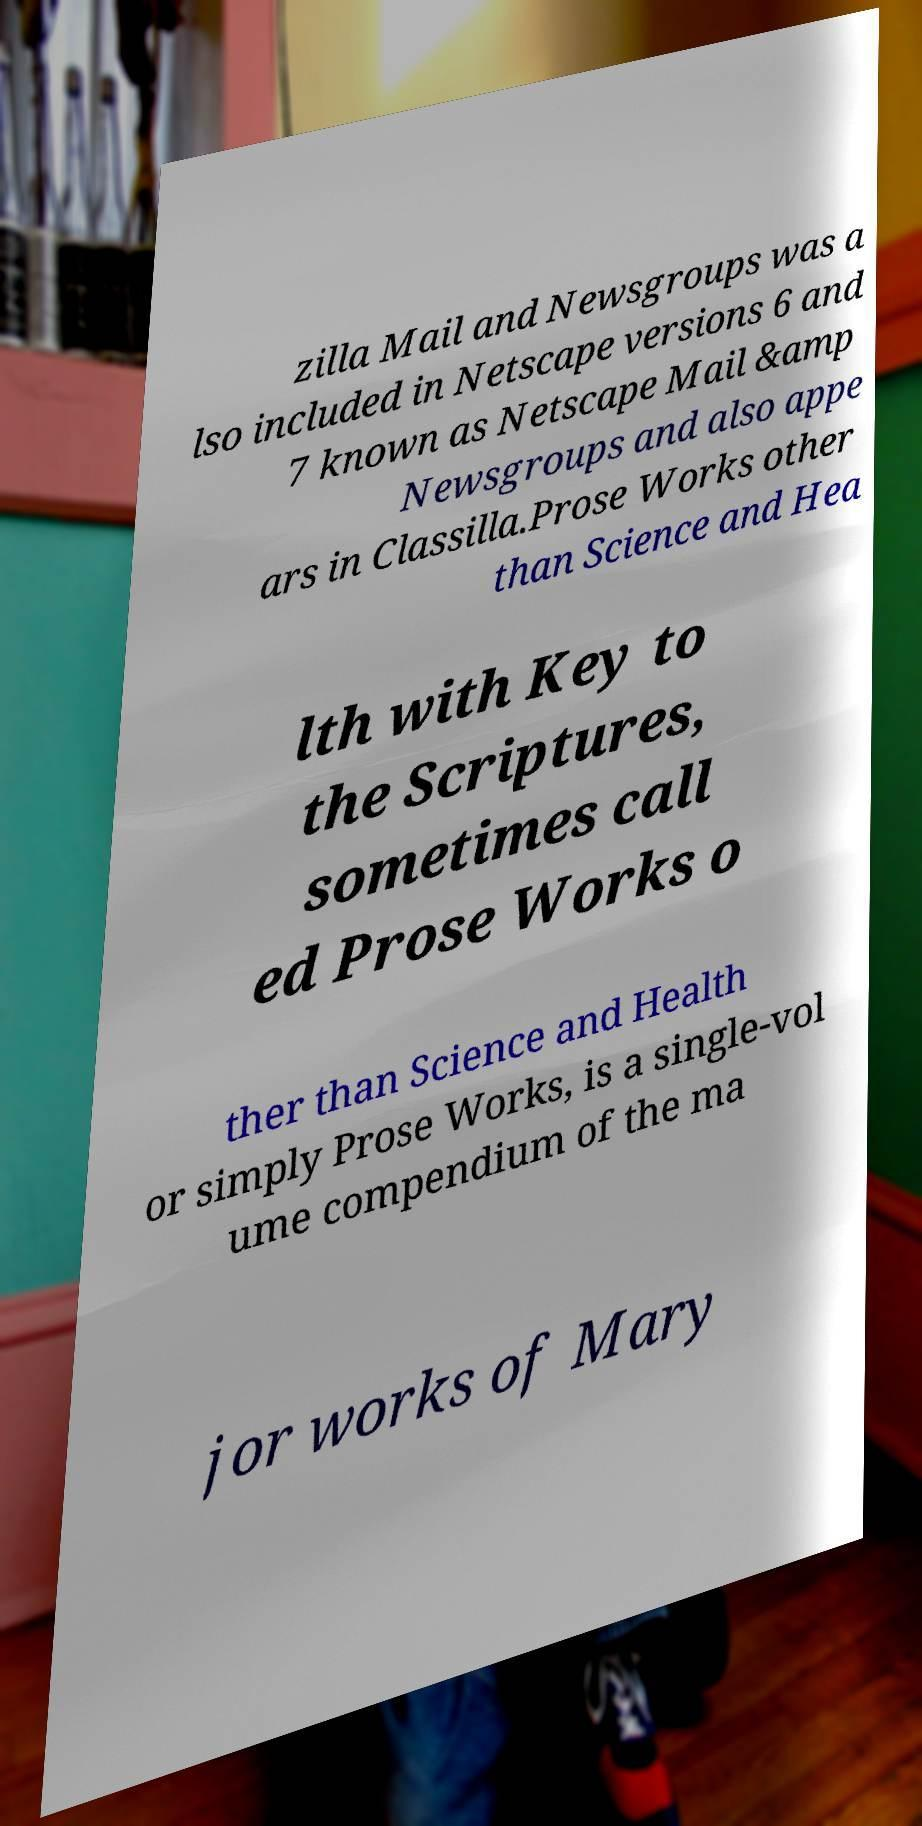Please identify and transcribe the text found in this image. zilla Mail and Newsgroups was a lso included in Netscape versions 6 and 7 known as Netscape Mail &amp Newsgroups and also appe ars in Classilla.Prose Works other than Science and Hea lth with Key to the Scriptures, sometimes call ed Prose Works o ther than Science and Health or simply Prose Works, is a single-vol ume compendium of the ma jor works of Mary 